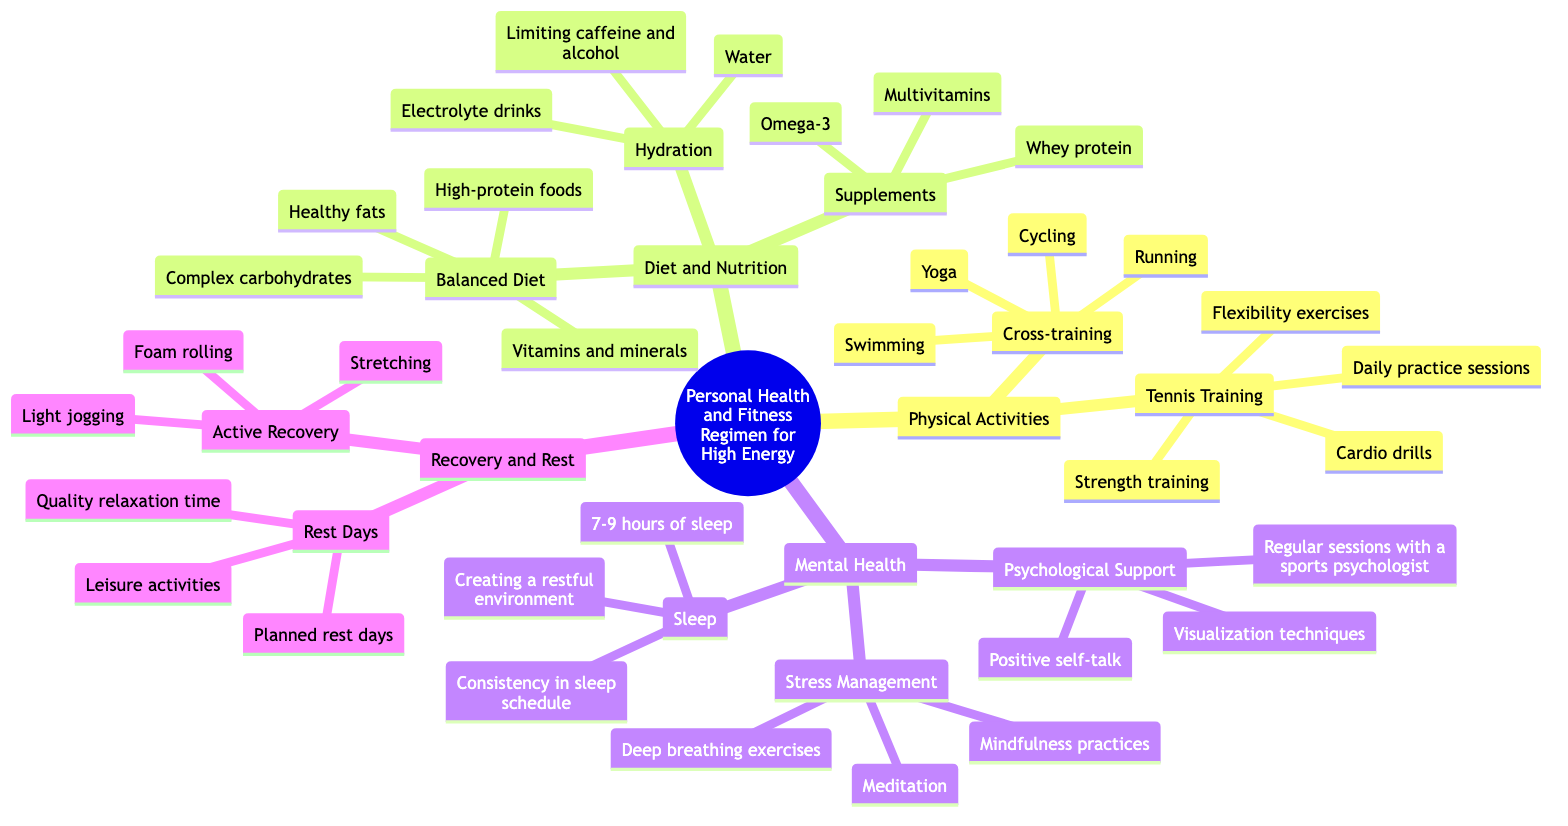What is the main category of the mind map? The main category is represented at the root of the diagram, which is "Personal Health and Fitness Regimen for High Energy."
Answer: Personal Health and Fitness Regimen for High Energy How many subcategories are under "Diet and Nutrition"? By counting the nodes directly under this category, we can see three subcategories: Balanced Diet, Hydration, and Supplements.
Answer: 3 Which physical activity has "Flexibility exercises" as a component? "Flexibility exercises" is listed as part of the "Tennis Training" subcategory, indicating it is one of the physical activities incorporated in tennis training.
Answer: Tennis Training What type of supplements are included in the regimen? The diagram provides three specific supplements under the "Supplements" node: Whey protein, Multivitamins, and Omega-3, which qualifies as part of the health regimen.
Answer: Whey protein, Multivitamins, Omega-3 What are the components of "Mental Health" relating to stress management? Under the "Mental Health" section, specifically within "Stress Management," there are three components: Meditation, Deep breathing exercises, and Mindfulness practices, all contributing to mental well-being.
Answer: Meditation, Deep breathing exercises, Mindfulness practices How many activities are listed under "Cross-training"? The diagram lists four activities under "Cross-training," which are Swimming, Cycling, Running, and Yoga, making it straightforward to count them.
Answer: 4 What is suggested for active recovery? Active Recovery suggests three key activities: Light jogging, Stretching, and Foam rolling. These are all methods to facilitate recovery without intense exertion.
Answer: Light jogging, Stretching, Foam rolling How many total components are in the "Recovery and Rest" section? The "Recovery and Rest" section splits into two categories, each of which contains three components; thus combining these gives us a total of six components under this section.
Answer: 6 